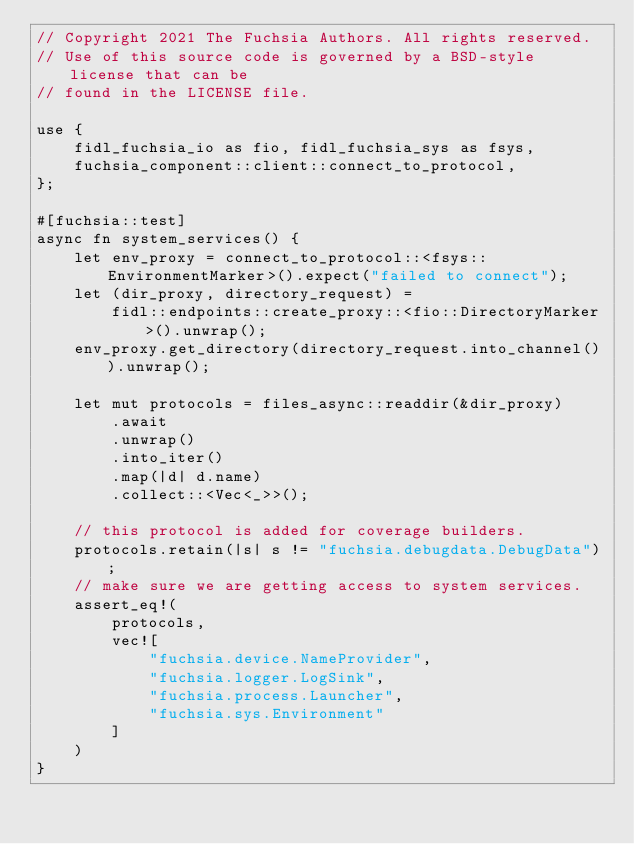Convert code to text. <code><loc_0><loc_0><loc_500><loc_500><_Rust_>// Copyright 2021 The Fuchsia Authors. All rights reserved.
// Use of this source code is governed by a BSD-style license that can be
// found in the LICENSE file.

use {
    fidl_fuchsia_io as fio, fidl_fuchsia_sys as fsys,
    fuchsia_component::client::connect_to_protocol,
};

#[fuchsia::test]
async fn system_services() {
    let env_proxy = connect_to_protocol::<fsys::EnvironmentMarker>().expect("failed to connect");
    let (dir_proxy, directory_request) =
        fidl::endpoints::create_proxy::<fio::DirectoryMarker>().unwrap();
    env_proxy.get_directory(directory_request.into_channel()).unwrap();

    let mut protocols = files_async::readdir(&dir_proxy)
        .await
        .unwrap()
        .into_iter()
        .map(|d| d.name)
        .collect::<Vec<_>>();

    // this protocol is added for coverage builders.
    protocols.retain(|s| s != "fuchsia.debugdata.DebugData");
    // make sure we are getting access to system services.
    assert_eq!(
        protocols,
        vec![
            "fuchsia.device.NameProvider",
            "fuchsia.logger.LogSink",
            "fuchsia.process.Launcher",
            "fuchsia.sys.Environment"
        ]
    )
}
</code> 